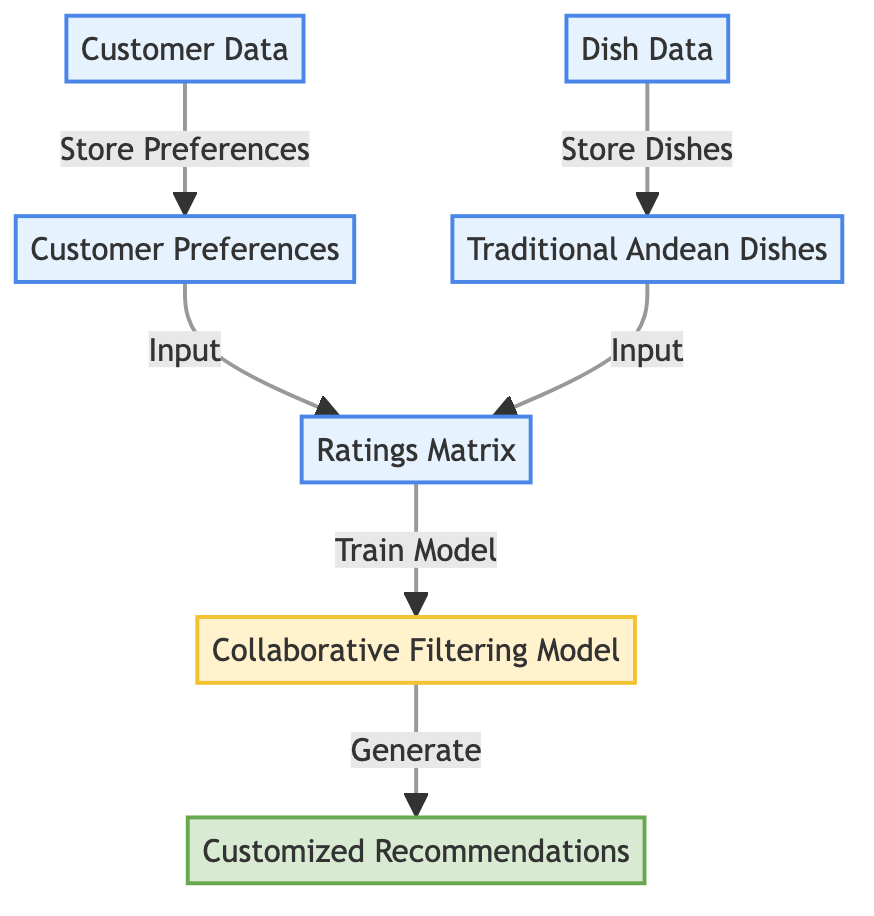What is the first node in the diagram? The first node in the diagram is labeled "Customer Preferences". It is positioned at the top left of the diagram, indicating it is the starting point of the flow.
Answer: Customer Preferences How many nodes are present in the diagram? Counting all unique elements represented visually, there are a total of seven nodes in the diagram. These include: Customer Preferences, Traditional Andean Dishes, Ratings Matrix, Collaborative Filtering Model, Customized Recommendations, Customer Data, and Dish Data.
Answer: Seven Which node receives input from both the Customer Preferences and Traditional Andean Dishes? The "Ratings Matrix" node is the one that receives input from both the Customer Preferences and Traditional Andean Dishes. This indicates it combines data from both sources to form a matrix for analysis.
Answer: Ratings Matrix What is the output of the Collaborative Filtering Model? The output of the Collaborative Filtering Model is "Customized Recommendations", indicating that once the model is trained, it generates tailored dish suggestions for customers based on their preferences.
Answer: Customized Recommendations What does the Customer Data node connect to? The Customer Data node connects to the Customer Preferences node, indicating that the data from customers is stored and subsequently used to define their preferences for Andean dishes.
Answer: Customer Preferences Which node indicates the training process of the model? The "Collaborative Filtering Model" node indicates the training process. It is a part of the workflow that specifically mentions "Train Model," demonstrating where the model learns from the input data.
Answer: Collaborative Filtering Model How does the Ratings Matrix contribute to the overall process? The Ratings Matrix acts as a foundational input for the Collaborative Filtering Model, allowing it to make predictions based on the structured data of customer preferences and dish ratings, leading to recommendations.
Answer: Collaborative Filtering Model What are the two types of data nodes represented in the diagram? The two types of data nodes represented in the diagram are "Customer Data" and "Dish Data." These nodes refer to the sources of information that feed into the recommendation system.
Answer: Customer Data and Dish Data 